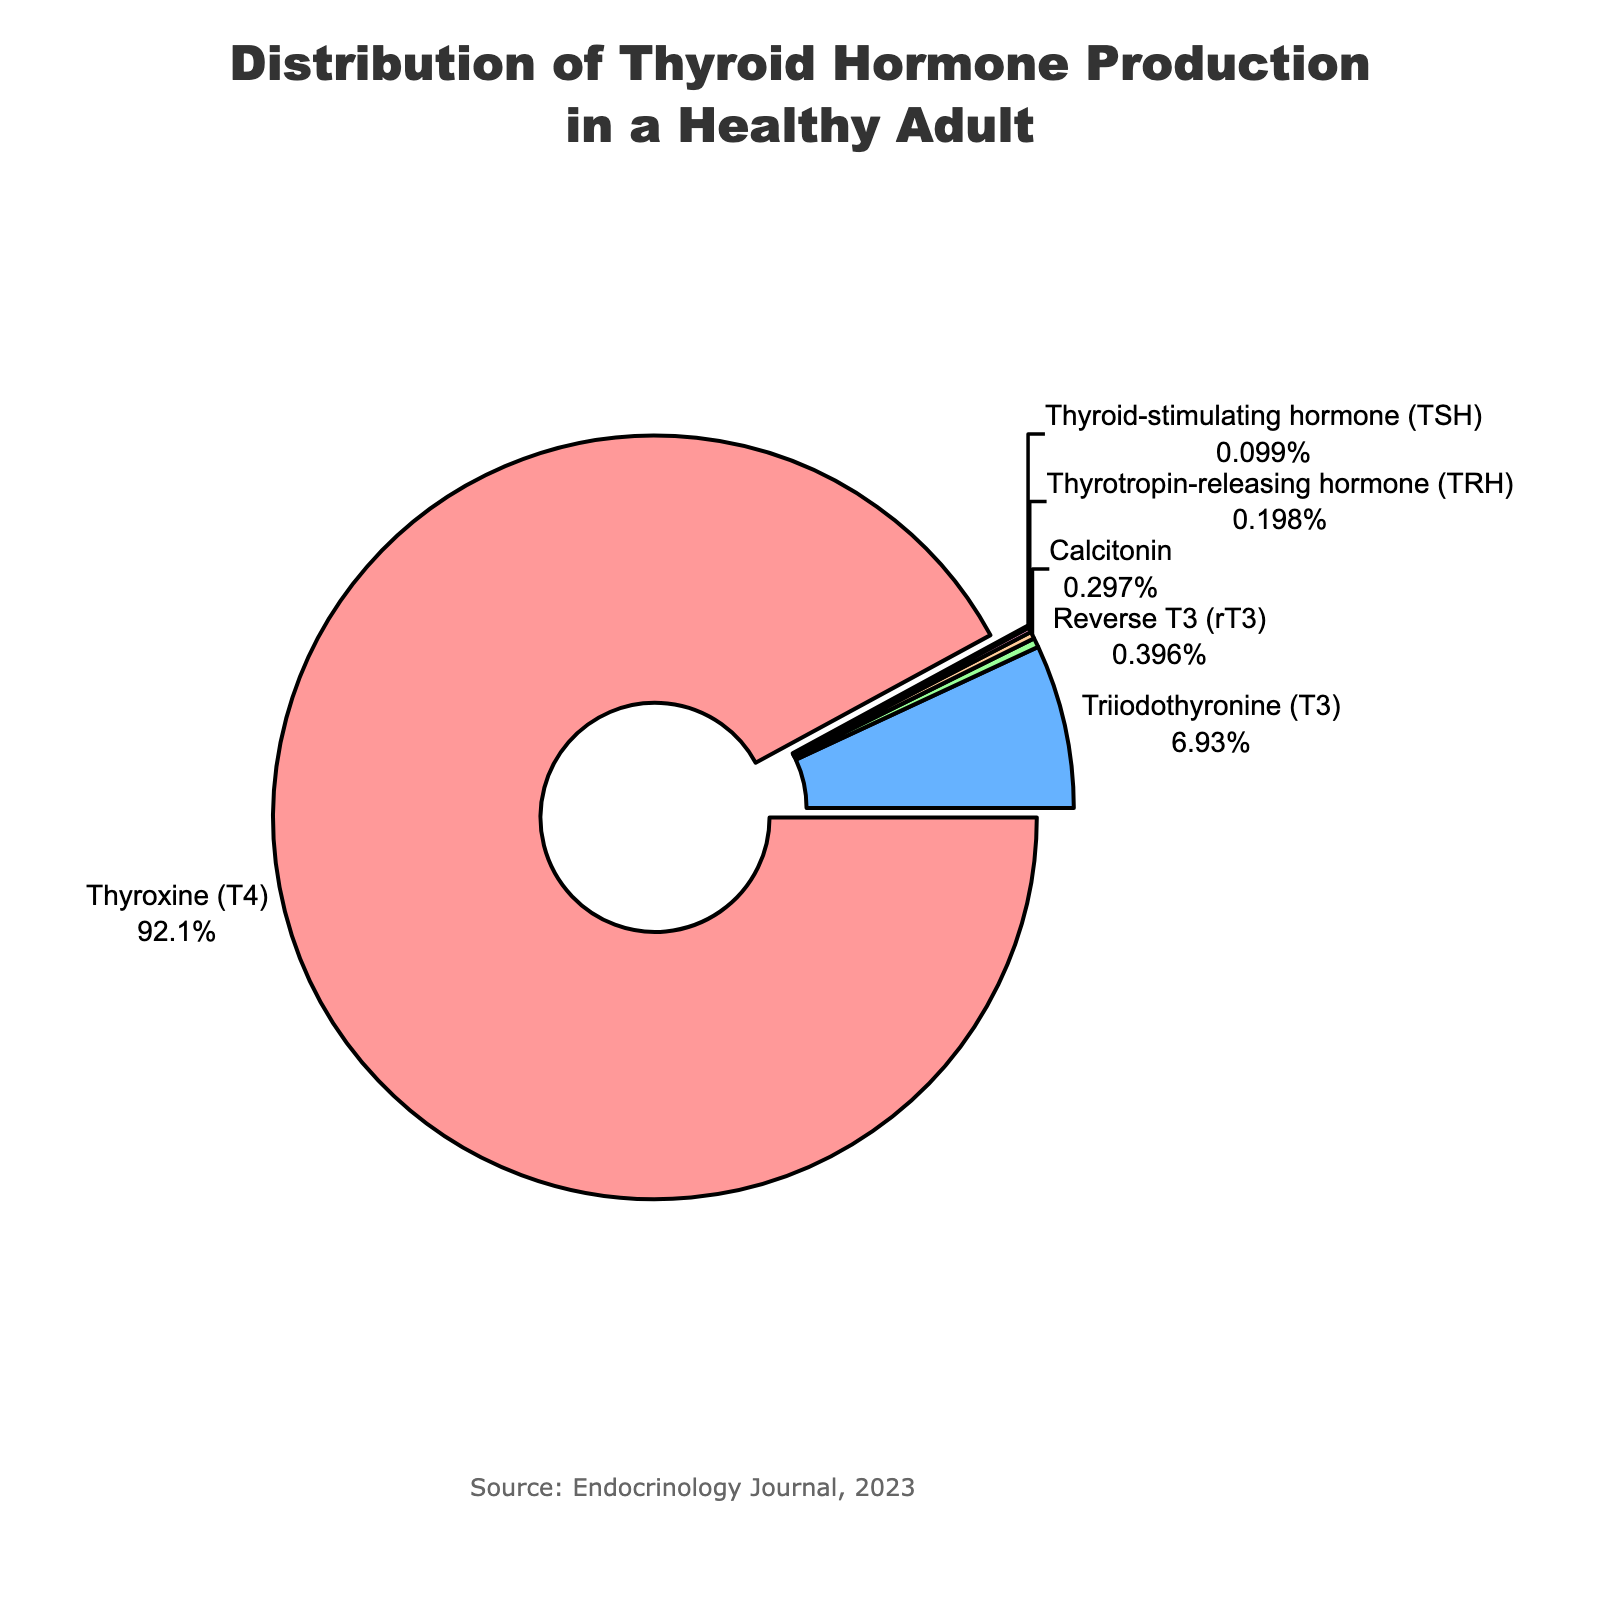Which hormone has the highest percentage production in a healthy adult? The pie chart shows different hormones with their corresponding percentages. The largest section of the pie chart represents Thyroxine (T4) at 93%.
Answer: Thyroxine (T4) Which hormone has the lowest percentage production? The pie chart has multiple slices, with the smallest one clearly labeled as Thyroid-stimulating hormone (TSH) at 0.1%.
Answer: Thyroid-stimulating hormone (TSH) What is the combined percentage of reverse T3 (rT3) and Calcitonin? From the pie chart, reverse T3 (rT3) has a percentage of 0.4% and Calcitonin has 0.3%. Adding them together: 0.4% + 0.3% = 0.7%.
Answer: 0.7% How much more of Thyroxine (T4) is produced compared to Triiodothyronine (T3)? The pie chart shows Thyroxine (T4) at 93% and Triiodothyronine (T3) at 7%. Subtracting them: 93% - 7% = 86%.
Answer: 86% What is the total percentage production of hormones other than Thyroxine (T4)? Sum the percentages of all hormones except Thyroxine (T4): Triiodothyronine (T3) 7%, reverse T3 (rT3) 0.4%, Calcitonin 0.3%, Thyrotropin-releasing hormone (TRH) 0.2%, and Thyroid-stimulating hormone (TSH) 0.1%. The total is 7% + 0.4% + 0.3% + 0.2% + 0.1% = 8%.
Answer: 8% Which hormone slice is colored red in the chart? The pie chart uses red for one of the segments, and this color is typically used to attract attention to the largest portion, which is Thyroxine (T4).
Answer: Thyroxine (T4) What is the difference in percentage between reverse T3 (rT3) and Thyrotropin-releasing hormone (TRH)? The chart indicates reverse T3 (rT3) at 0.4% and Thyrotropin-releasing hormone (TRH) at 0.2%. Subtracting them: 0.4% - 0.2% = 0.2%.
Answer: 0.2% 